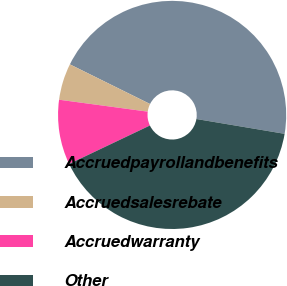Convert chart. <chart><loc_0><loc_0><loc_500><loc_500><pie_chart><fcel>Accruedpayrollandbenefits<fcel>Accruedsalesrebate<fcel>Accruedwarranty<fcel>Other<nl><fcel>45.34%<fcel>5.18%<fcel>9.2%<fcel>40.28%<nl></chart> 